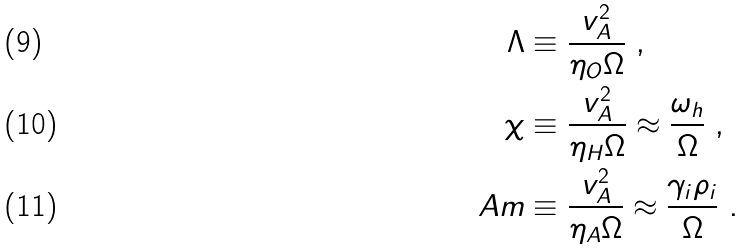<formula> <loc_0><loc_0><loc_500><loc_500>\Lambda & \equiv \frac { v _ { A } ^ { 2 } } { \eta _ { O } \Omega } \ , \\ \chi & \equiv \frac { v _ { A } ^ { 2 } } { \eta _ { H } \Omega } \approx \frac { \omega _ { h } } { \Omega } \ , \\ A m & \equiv \frac { v _ { A } ^ { 2 } } { \eta _ { A } \Omega } \approx \frac { \gamma _ { i } \rho _ { i } } { \Omega } \ .</formula> 